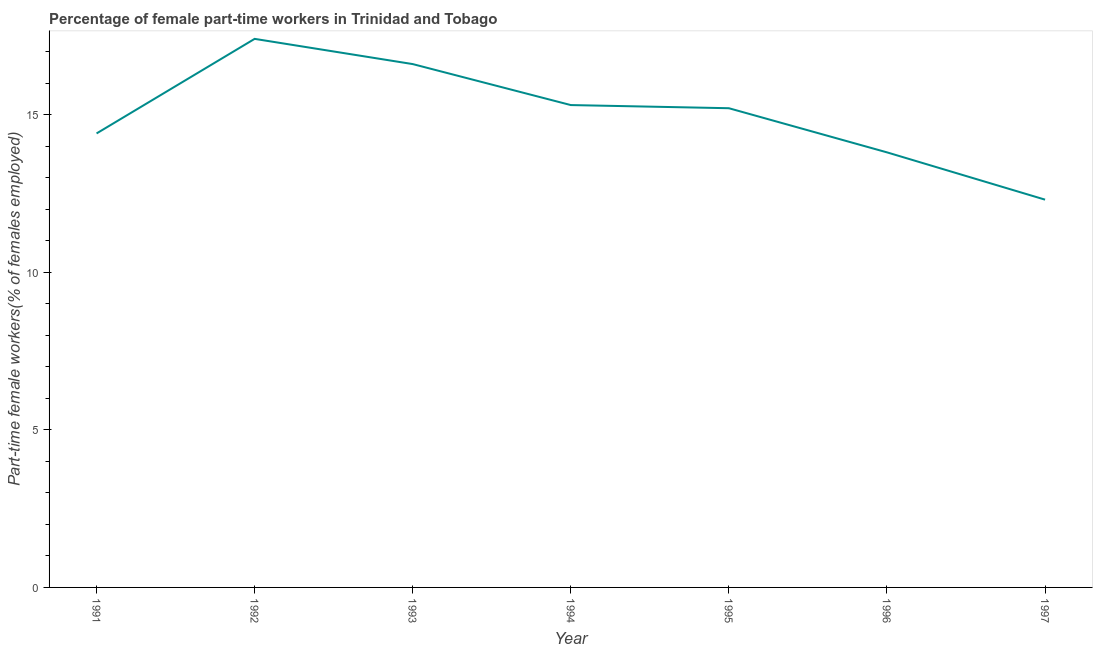What is the percentage of part-time female workers in 1991?
Your response must be concise. 14.4. Across all years, what is the maximum percentage of part-time female workers?
Give a very brief answer. 17.4. Across all years, what is the minimum percentage of part-time female workers?
Give a very brief answer. 12.3. In which year was the percentage of part-time female workers maximum?
Offer a terse response. 1992. What is the sum of the percentage of part-time female workers?
Your response must be concise. 105. What is the difference between the percentage of part-time female workers in 1991 and 1993?
Make the answer very short. -2.2. What is the average percentage of part-time female workers per year?
Your answer should be compact. 15. What is the median percentage of part-time female workers?
Your answer should be very brief. 15.2. In how many years, is the percentage of part-time female workers greater than 15 %?
Your response must be concise. 4. Do a majority of the years between 1997 and 1991 (inclusive) have percentage of part-time female workers greater than 14 %?
Provide a short and direct response. Yes. What is the ratio of the percentage of part-time female workers in 1994 to that in 1995?
Offer a very short reply. 1.01. What is the difference between the highest and the second highest percentage of part-time female workers?
Keep it short and to the point. 0.8. What is the difference between the highest and the lowest percentage of part-time female workers?
Your response must be concise. 5.1. Does the percentage of part-time female workers monotonically increase over the years?
Ensure brevity in your answer.  No. How many years are there in the graph?
Your answer should be very brief. 7. What is the difference between two consecutive major ticks on the Y-axis?
Your response must be concise. 5. Does the graph contain grids?
Make the answer very short. No. What is the title of the graph?
Your answer should be very brief. Percentage of female part-time workers in Trinidad and Tobago. What is the label or title of the X-axis?
Your answer should be compact. Year. What is the label or title of the Y-axis?
Your answer should be very brief. Part-time female workers(% of females employed). What is the Part-time female workers(% of females employed) of 1991?
Your answer should be very brief. 14.4. What is the Part-time female workers(% of females employed) of 1992?
Offer a very short reply. 17.4. What is the Part-time female workers(% of females employed) in 1993?
Keep it short and to the point. 16.6. What is the Part-time female workers(% of females employed) of 1994?
Make the answer very short. 15.3. What is the Part-time female workers(% of females employed) in 1995?
Make the answer very short. 15.2. What is the Part-time female workers(% of females employed) of 1996?
Provide a short and direct response. 13.8. What is the Part-time female workers(% of females employed) in 1997?
Offer a very short reply. 12.3. What is the difference between the Part-time female workers(% of females employed) in 1991 and 1992?
Provide a short and direct response. -3. What is the difference between the Part-time female workers(% of females employed) in 1991 and 1993?
Your answer should be very brief. -2.2. What is the difference between the Part-time female workers(% of females employed) in 1991 and 1994?
Your answer should be compact. -0.9. What is the difference between the Part-time female workers(% of females employed) in 1991 and 1995?
Give a very brief answer. -0.8. What is the difference between the Part-time female workers(% of females employed) in 1991 and 1996?
Your answer should be compact. 0.6. What is the difference between the Part-time female workers(% of females employed) in 1991 and 1997?
Your answer should be very brief. 2.1. What is the difference between the Part-time female workers(% of females employed) in 1992 and 1993?
Ensure brevity in your answer.  0.8. What is the difference between the Part-time female workers(% of females employed) in 1992 and 1994?
Offer a very short reply. 2.1. What is the difference between the Part-time female workers(% of females employed) in 1993 and 1994?
Provide a succinct answer. 1.3. What is the difference between the Part-time female workers(% of females employed) in 1993 and 1995?
Ensure brevity in your answer.  1.4. What is the difference between the Part-time female workers(% of females employed) in 1993 and 1996?
Your answer should be compact. 2.8. What is the difference between the Part-time female workers(% of females employed) in 1994 and 1997?
Keep it short and to the point. 3. What is the difference between the Part-time female workers(% of females employed) in 1995 and 1997?
Your answer should be very brief. 2.9. What is the ratio of the Part-time female workers(% of females employed) in 1991 to that in 1992?
Keep it short and to the point. 0.83. What is the ratio of the Part-time female workers(% of females employed) in 1991 to that in 1993?
Your answer should be compact. 0.87. What is the ratio of the Part-time female workers(% of females employed) in 1991 to that in 1994?
Your answer should be compact. 0.94. What is the ratio of the Part-time female workers(% of females employed) in 1991 to that in 1995?
Your answer should be compact. 0.95. What is the ratio of the Part-time female workers(% of females employed) in 1991 to that in 1996?
Keep it short and to the point. 1.04. What is the ratio of the Part-time female workers(% of females employed) in 1991 to that in 1997?
Your answer should be compact. 1.17. What is the ratio of the Part-time female workers(% of females employed) in 1992 to that in 1993?
Offer a terse response. 1.05. What is the ratio of the Part-time female workers(% of females employed) in 1992 to that in 1994?
Give a very brief answer. 1.14. What is the ratio of the Part-time female workers(% of females employed) in 1992 to that in 1995?
Ensure brevity in your answer.  1.15. What is the ratio of the Part-time female workers(% of females employed) in 1992 to that in 1996?
Your answer should be very brief. 1.26. What is the ratio of the Part-time female workers(% of females employed) in 1992 to that in 1997?
Give a very brief answer. 1.42. What is the ratio of the Part-time female workers(% of females employed) in 1993 to that in 1994?
Offer a terse response. 1.08. What is the ratio of the Part-time female workers(% of females employed) in 1993 to that in 1995?
Your answer should be very brief. 1.09. What is the ratio of the Part-time female workers(% of females employed) in 1993 to that in 1996?
Offer a very short reply. 1.2. What is the ratio of the Part-time female workers(% of females employed) in 1993 to that in 1997?
Provide a short and direct response. 1.35. What is the ratio of the Part-time female workers(% of females employed) in 1994 to that in 1995?
Give a very brief answer. 1.01. What is the ratio of the Part-time female workers(% of females employed) in 1994 to that in 1996?
Your answer should be very brief. 1.11. What is the ratio of the Part-time female workers(% of females employed) in 1994 to that in 1997?
Provide a succinct answer. 1.24. What is the ratio of the Part-time female workers(% of females employed) in 1995 to that in 1996?
Give a very brief answer. 1.1. What is the ratio of the Part-time female workers(% of females employed) in 1995 to that in 1997?
Offer a terse response. 1.24. What is the ratio of the Part-time female workers(% of females employed) in 1996 to that in 1997?
Make the answer very short. 1.12. 